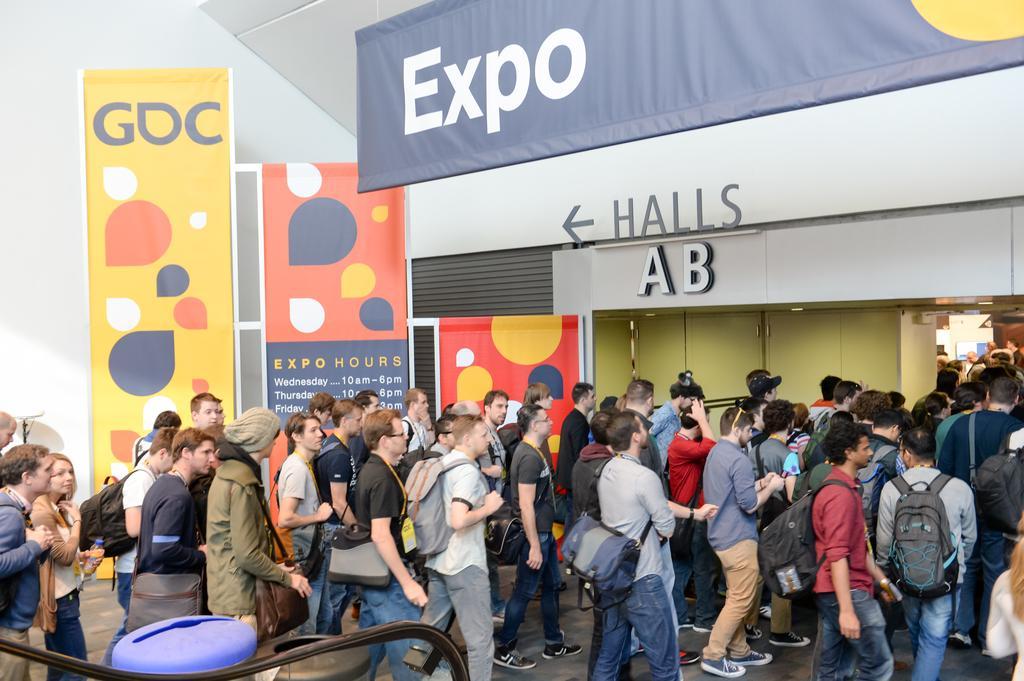How would you summarize this image in a sentence or two? In this image at the bottom there are a group of people who are walking, and some of them are wearing bags. And at the bottom there is a walkway, and in the background there are some boards, hoardings and buildings and some doors and lights. 